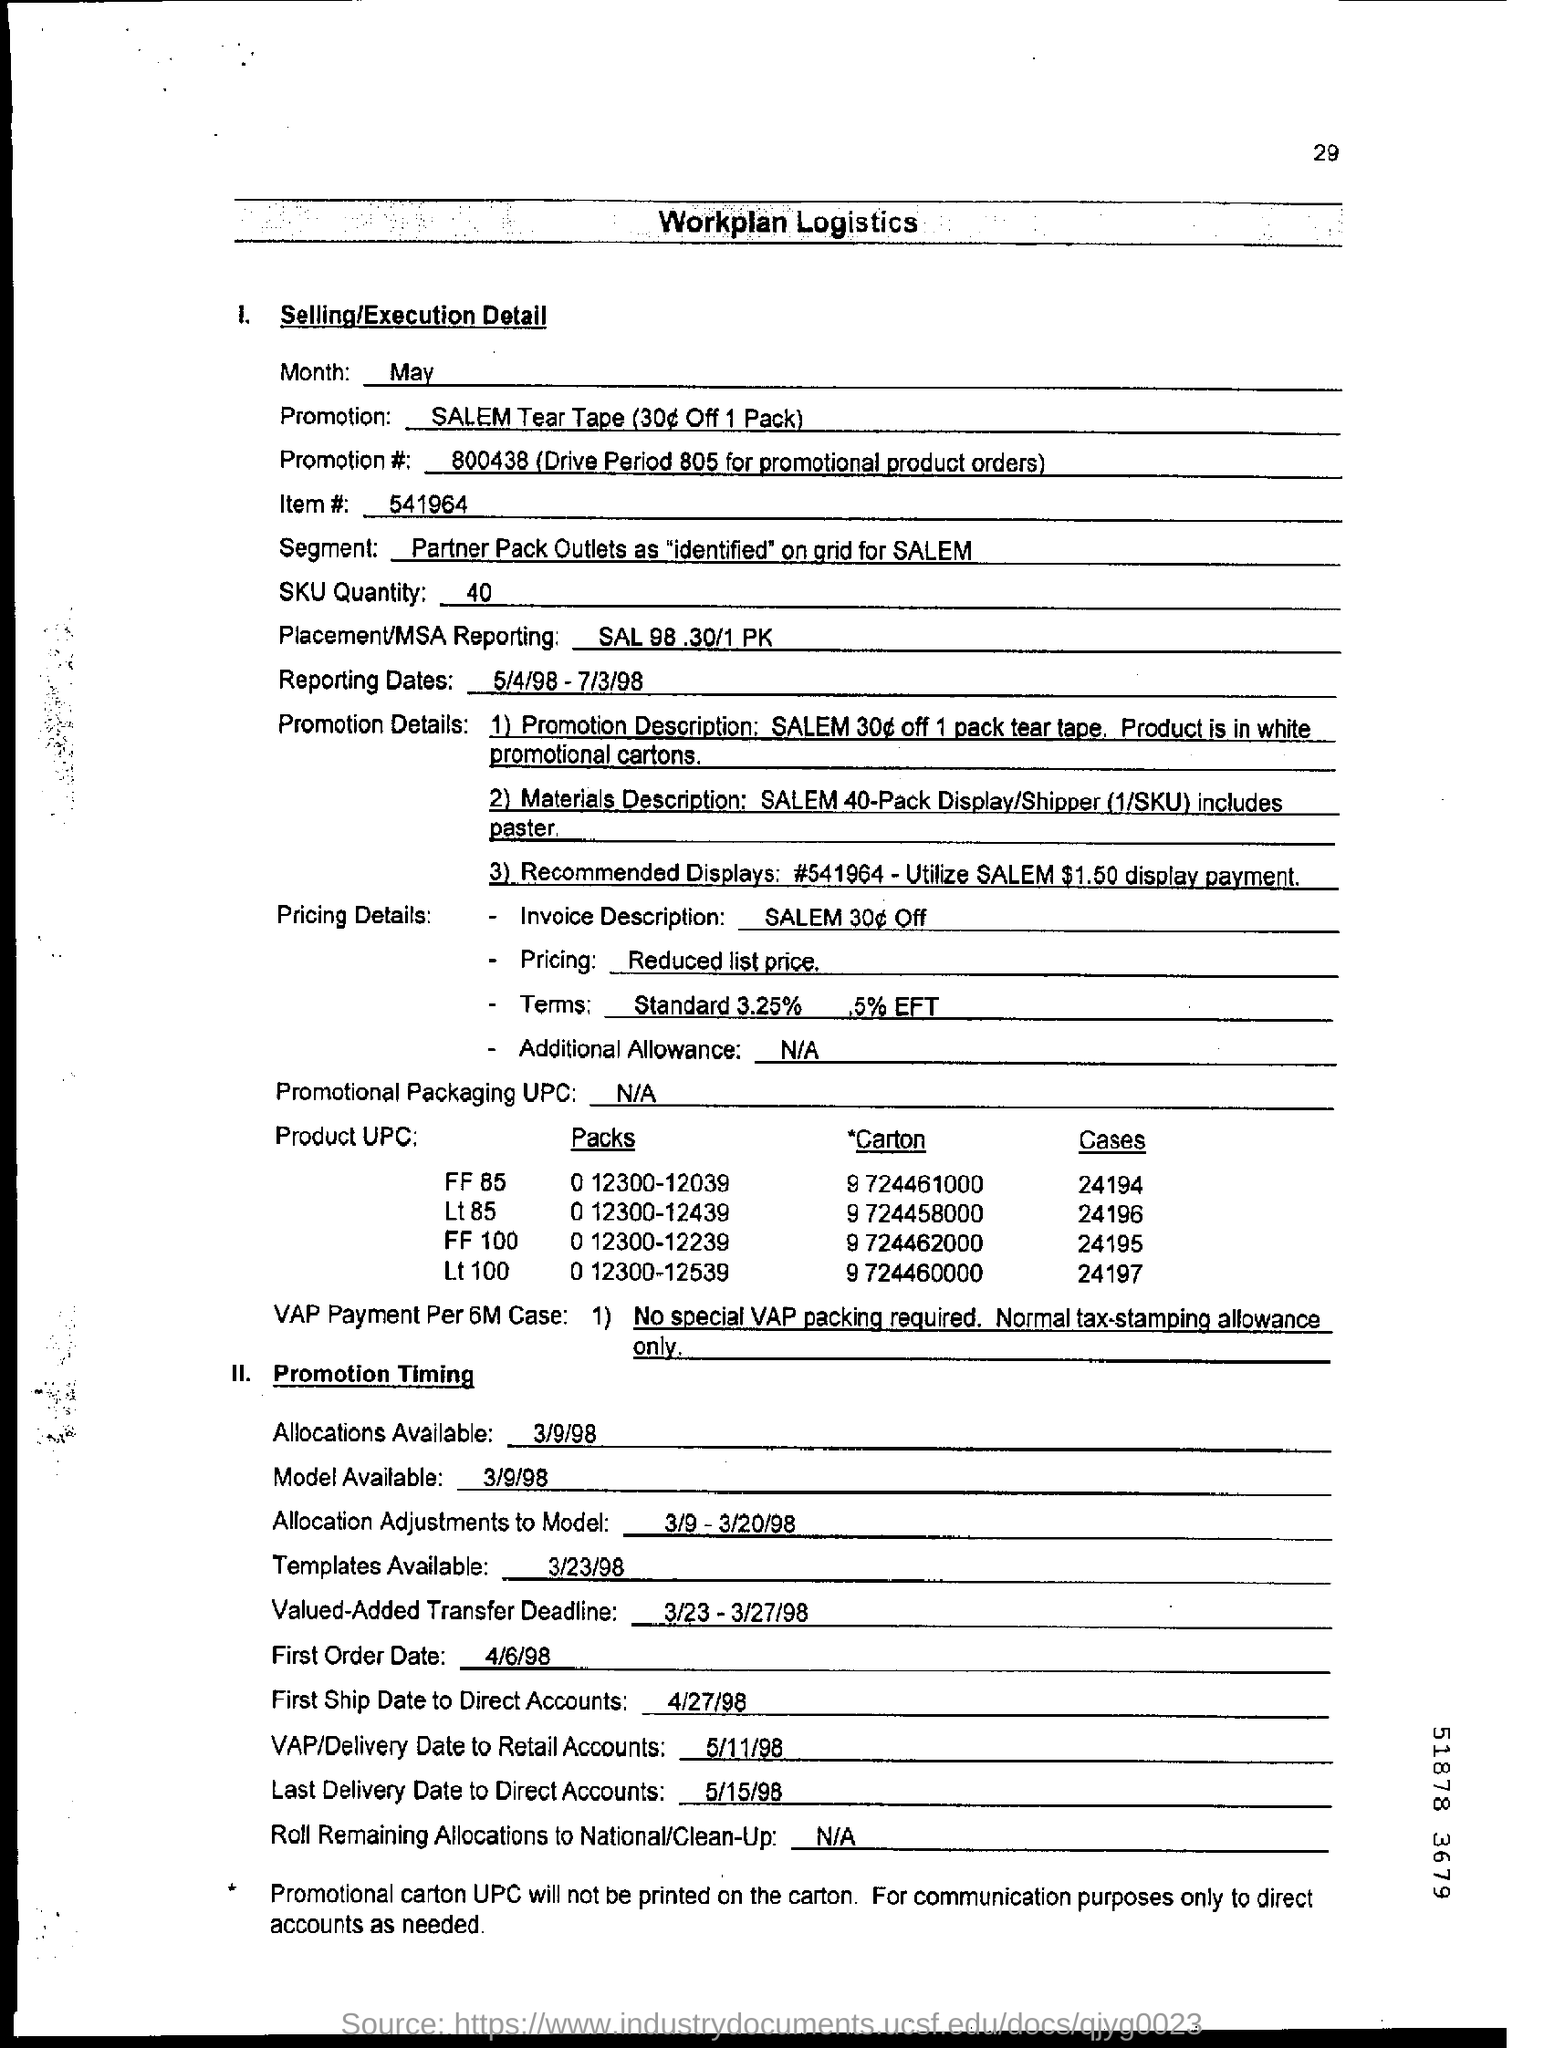Identify some key points in this picture. The last date to deliver direct accounts is May 15th, 1998. 